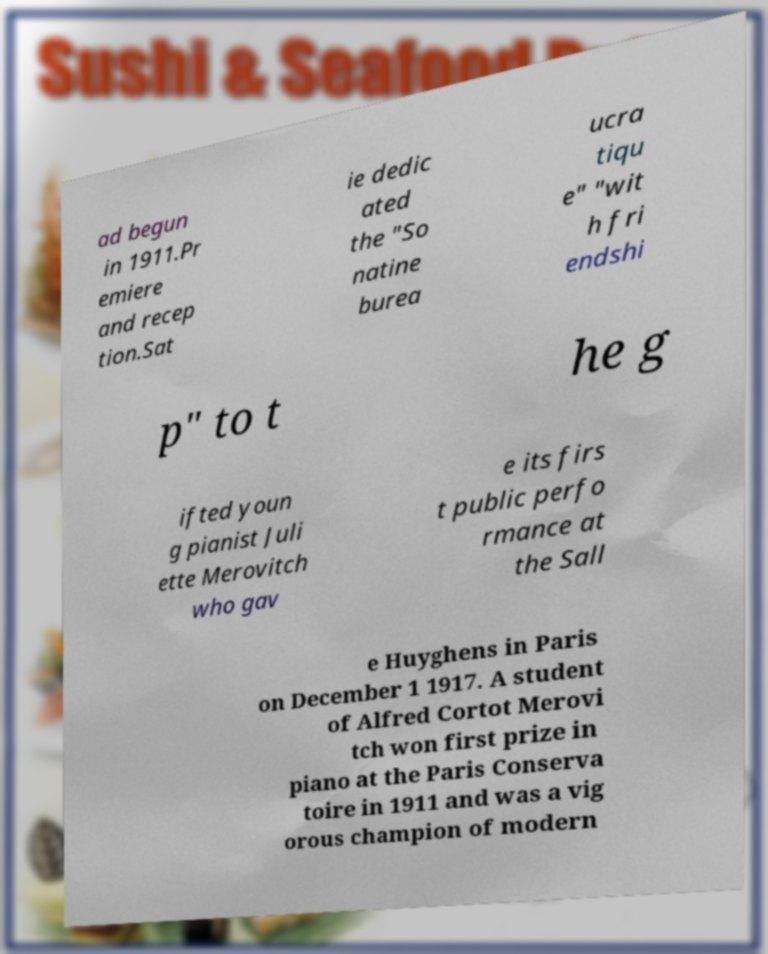There's text embedded in this image that I need extracted. Can you transcribe it verbatim? ad begun in 1911.Pr emiere and recep tion.Sat ie dedic ated the "So natine burea ucra tiqu e" "wit h fri endshi p" to t he g ifted youn g pianist Juli ette Merovitch who gav e its firs t public perfo rmance at the Sall e Huyghens in Paris on December 1 1917. A student of Alfred Cortot Merovi tch won first prize in piano at the Paris Conserva toire in 1911 and was a vig orous champion of modern 